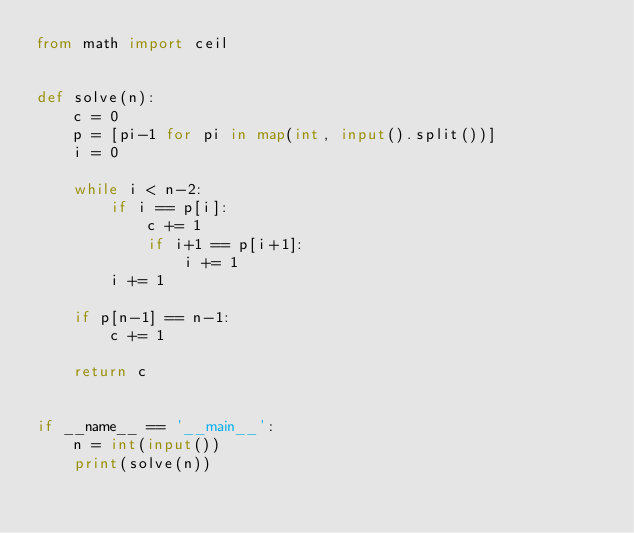<code> <loc_0><loc_0><loc_500><loc_500><_Python_>from math import ceil


def solve(n):
    c = 0
    p = [pi-1 for pi in map(int, input().split())]
    i = 0

    while i < n-2:
        if i == p[i]:
            c += 1
            if i+1 == p[i+1]:
                i += 1
        i += 1

    if p[n-1] == n-1:
        c += 1

    return c


if __name__ == '__main__':
    n = int(input())
    print(solve(n))
</code> 